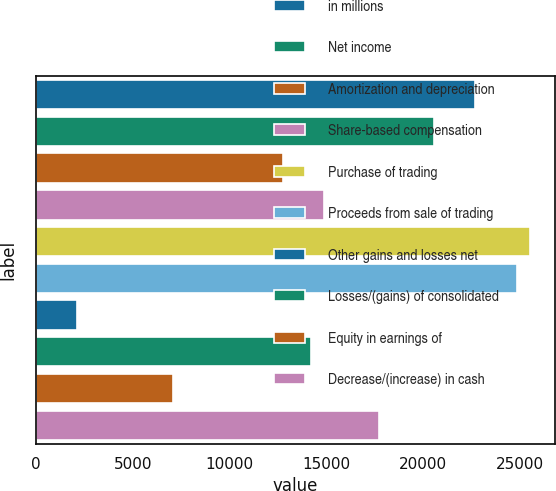Convert chart. <chart><loc_0><loc_0><loc_500><loc_500><bar_chart><fcel>in millions<fcel>Net income<fcel>Amortization and depreciation<fcel>Share-based compensation<fcel>Purchase of trading<fcel>Proceeds from sale of trading<fcel>Other gains and losses net<fcel>Losses/(gains) of consolidated<fcel>Equity in earnings of<fcel>Decrease/(increase) in cash<nl><fcel>22691.3<fcel>20564.3<fcel>12765.2<fcel>14892.2<fcel>25527.4<fcel>24818.3<fcel>2130.03<fcel>14183.2<fcel>7093.1<fcel>17728.2<nl></chart> 